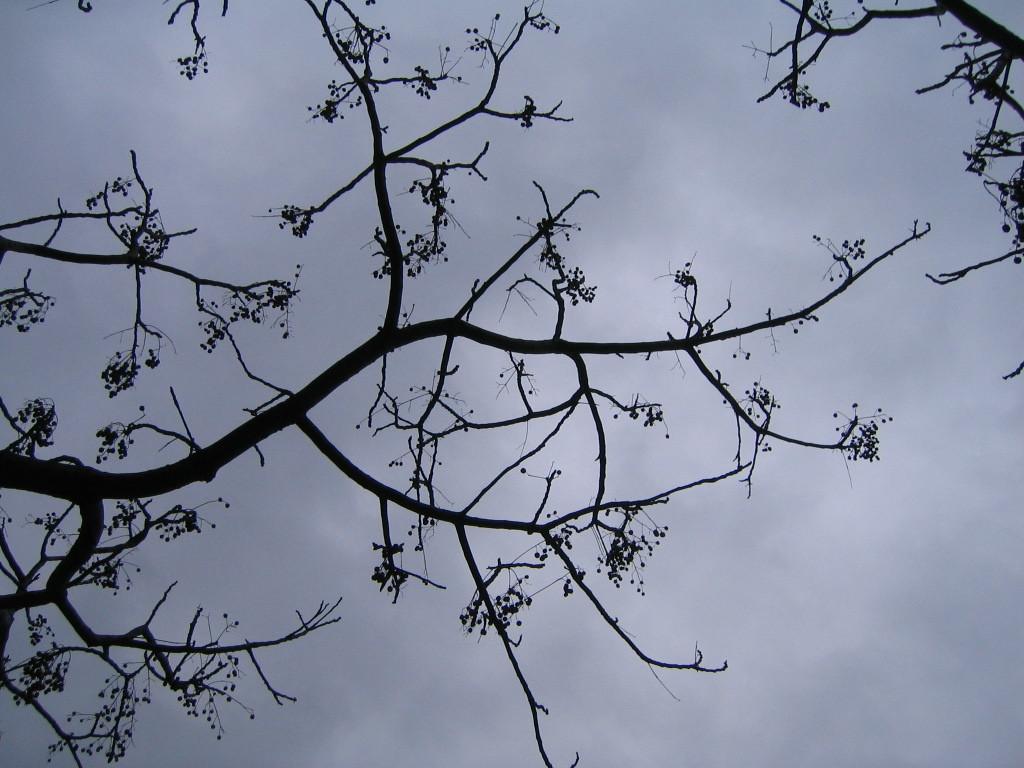How would you summarize this image in a sentence or two? In this image there are some trees, and in the background there is sky and the sky is cloudy. 